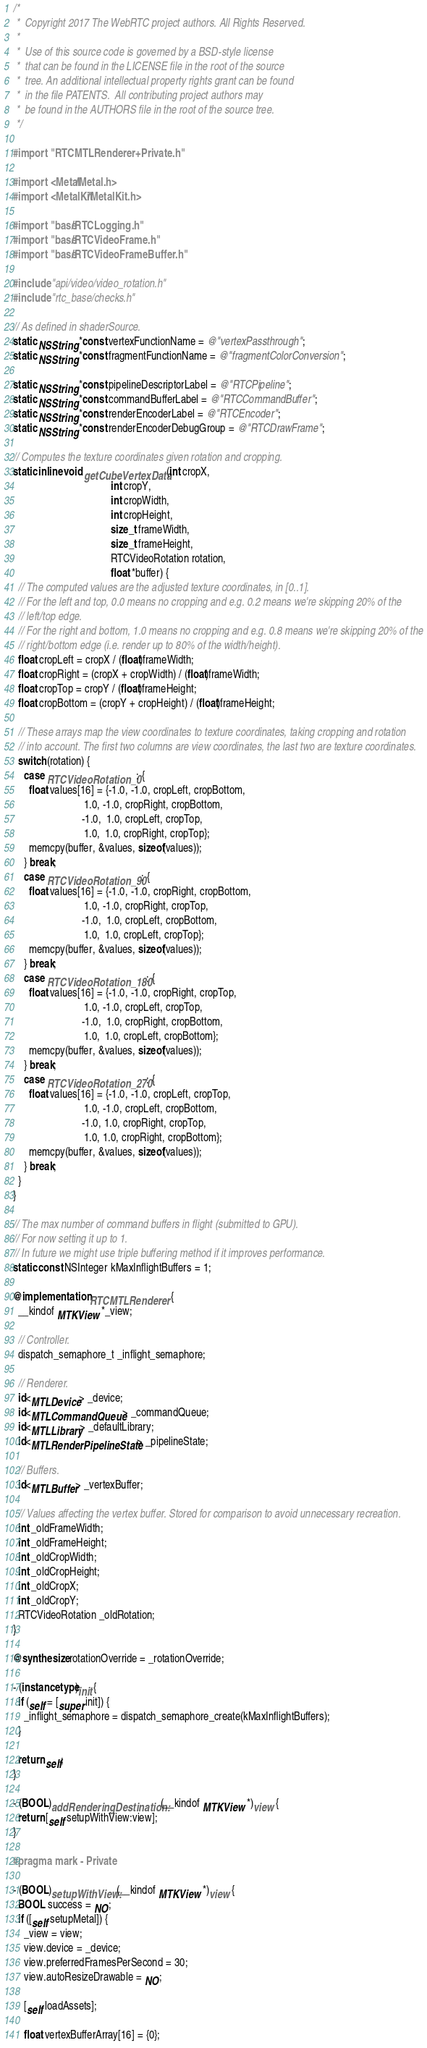Convert code to text. <code><loc_0><loc_0><loc_500><loc_500><_ObjectiveC_>/*
 *  Copyright 2017 The WebRTC project authors. All Rights Reserved.
 *
 *  Use of this source code is governed by a BSD-style license
 *  that can be found in the LICENSE file in the root of the source
 *  tree. An additional intellectual property rights grant can be found
 *  in the file PATENTS.  All contributing project authors may
 *  be found in the AUTHORS file in the root of the source tree.
 */

#import "RTCMTLRenderer+Private.h"

#import <Metal/Metal.h>
#import <MetalKit/MetalKit.h>

#import "base/RTCLogging.h"
#import "base/RTCVideoFrame.h"
#import "base/RTCVideoFrameBuffer.h"

#include "api/video/video_rotation.h"
#include "rtc_base/checks.h"

// As defined in shaderSource.
static NSString *const vertexFunctionName = @"vertexPassthrough";
static NSString *const fragmentFunctionName = @"fragmentColorConversion";

static NSString *const pipelineDescriptorLabel = @"RTCPipeline";
static NSString *const commandBufferLabel = @"RTCCommandBuffer";
static NSString *const renderEncoderLabel = @"RTCEncoder";
static NSString *const renderEncoderDebugGroup = @"RTCDrawFrame";

// Computes the texture coordinates given rotation and cropping.
static inline void getCubeVertexData(int cropX,
                                     int cropY,
                                     int cropWidth,
                                     int cropHeight,
                                     size_t frameWidth,
                                     size_t frameHeight,
                                     RTCVideoRotation rotation,
                                     float *buffer) {
  // The computed values are the adjusted texture coordinates, in [0..1].
  // For the left and top, 0.0 means no cropping and e.g. 0.2 means we're skipping 20% of the
  // left/top edge.
  // For the right and bottom, 1.0 means no cropping and e.g. 0.8 means we're skipping 20% of the
  // right/bottom edge (i.e. render up to 80% of the width/height).
  float cropLeft = cropX / (float)frameWidth;
  float cropRight = (cropX + cropWidth) / (float)frameWidth;
  float cropTop = cropY / (float)frameHeight;
  float cropBottom = (cropY + cropHeight) / (float)frameHeight;

  // These arrays map the view coordinates to texture coordinates, taking cropping and rotation
  // into account. The first two columns are view coordinates, the last two are texture coordinates.
  switch (rotation) {
    case RTCVideoRotation_0: {
      float values[16] = {-1.0, -1.0, cropLeft, cropBottom,
                           1.0, -1.0, cropRight, cropBottom,
                          -1.0,  1.0, cropLeft, cropTop,
                           1.0,  1.0, cropRight, cropTop};
      memcpy(buffer, &values, sizeof(values));
    } break;
    case RTCVideoRotation_90: {
      float values[16] = {-1.0, -1.0, cropRight, cropBottom,
                           1.0, -1.0, cropRight, cropTop,
                          -1.0,  1.0, cropLeft, cropBottom,
                           1.0,  1.0, cropLeft, cropTop};
      memcpy(buffer, &values, sizeof(values));
    } break;
    case RTCVideoRotation_180: {
      float values[16] = {-1.0, -1.0, cropRight, cropTop,
                           1.0, -1.0, cropLeft, cropTop,
                          -1.0,  1.0, cropRight, cropBottom,
                           1.0,  1.0, cropLeft, cropBottom};
      memcpy(buffer, &values, sizeof(values));
    } break;
    case RTCVideoRotation_270: {
      float values[16] = {-1.0, -1.0, cropLeft, cropTop,
                           1.0, -1.0, cropLeft, cropBottom,
                          -1.0, 1.0, cropRight, cropTop,
                           1.0, 1.0, cropRight, cropBottom};
      memcpy(buffer, &values, sizeof(values));
    } break;
  }
}

// The max number of command buffers in flight (submitted to GPU).
// For now setting it up to 1.
// In future we might use triple buffering method if it improves performance.
static const NSInteger kMaxInflightBuffers = 1;

@implementation RTCMTLRenderer {
  __kindof MTKView *_view;

  // Controller.
  dispatch_semaphore_t _inflight_semaphore;

  // Renderer.
  id<MTLDevice> _device;
  id<MTLCommandQueue> _commandQueue;
  id<MTLLibrary> _defaultLibrary;
  id<MTLRenderPipelineState> _pipelineState;

  // Buffers.
  id<MTLBuffer> _vertexBuffer;

  // Values affecting the vertex buffer. Stored for comparison to avoid unnecessary recreation.
  int _oldFrameWidth;
  int _oldFrameHeight;
  int _oldCropWidth;
  int _oldCropHeight;
  int _oldCropX;
  int _oldCropY;
  RTCVideoRotation _oldRotation;
}

@synthesize rotationOverride = _rotationOverride;

- (instancetype)init {
  if (self = [super init]) {
    _inflight_semaphore = dispatch_semaphore_create(kMaxInflightBuffers);
  }

  return self;
}

- (BOOL)addRenderingDestination:(__kindof MTKView *)view {
  return [self setupWithView:view];
}

#pragma mark - Private

- (BOOL)setupWithView:(__kindof MTKView *)view {
  BOOL success = NO;
  if ([self setupMetal]) {
    _view = view;
    view.device = _device;
    view.preferredFramesPerSecond = 30;
    view.autoResizeDrawable = NO;

    [self loadAssets];

    float vertexBufferArray[16] = {0};</code> 